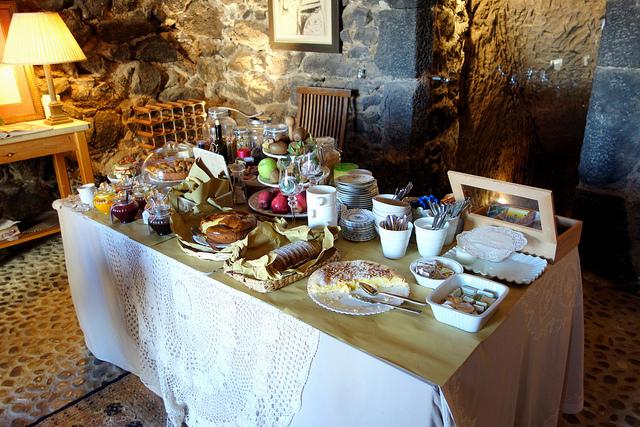Who is in the photo?
Concise answer only. No one. Are any lights on?
Quick response, please. Yes. Does this look like a special occasion event?
Give a very brief answer. Yes. 